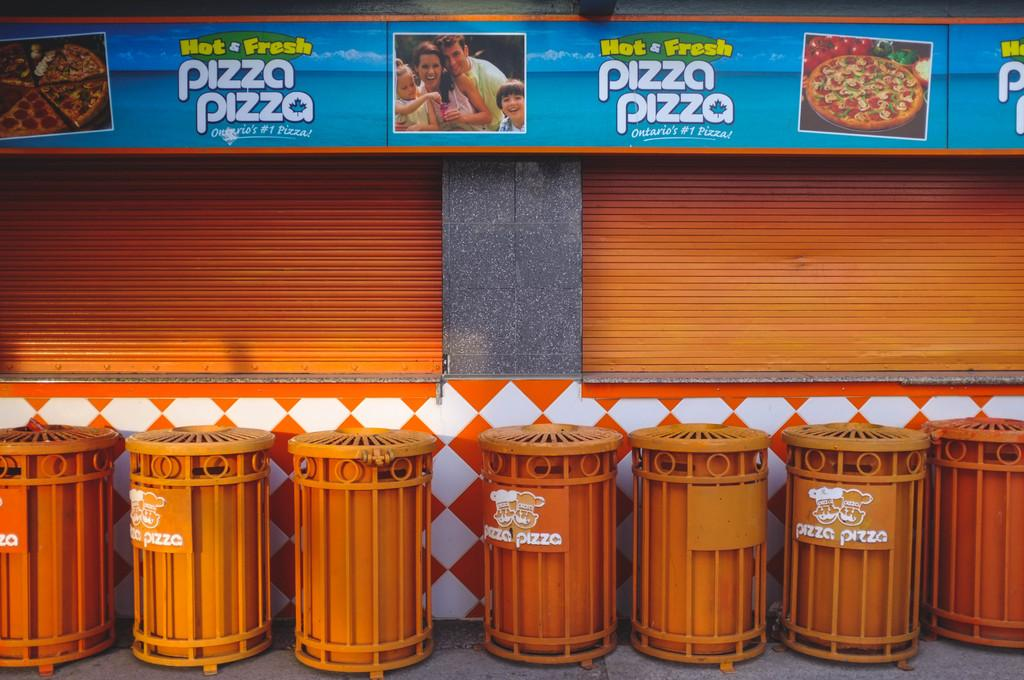Provide a one-sentence caption for the provided image. Orange bins in front of a wall which says Pizza Pizza. 